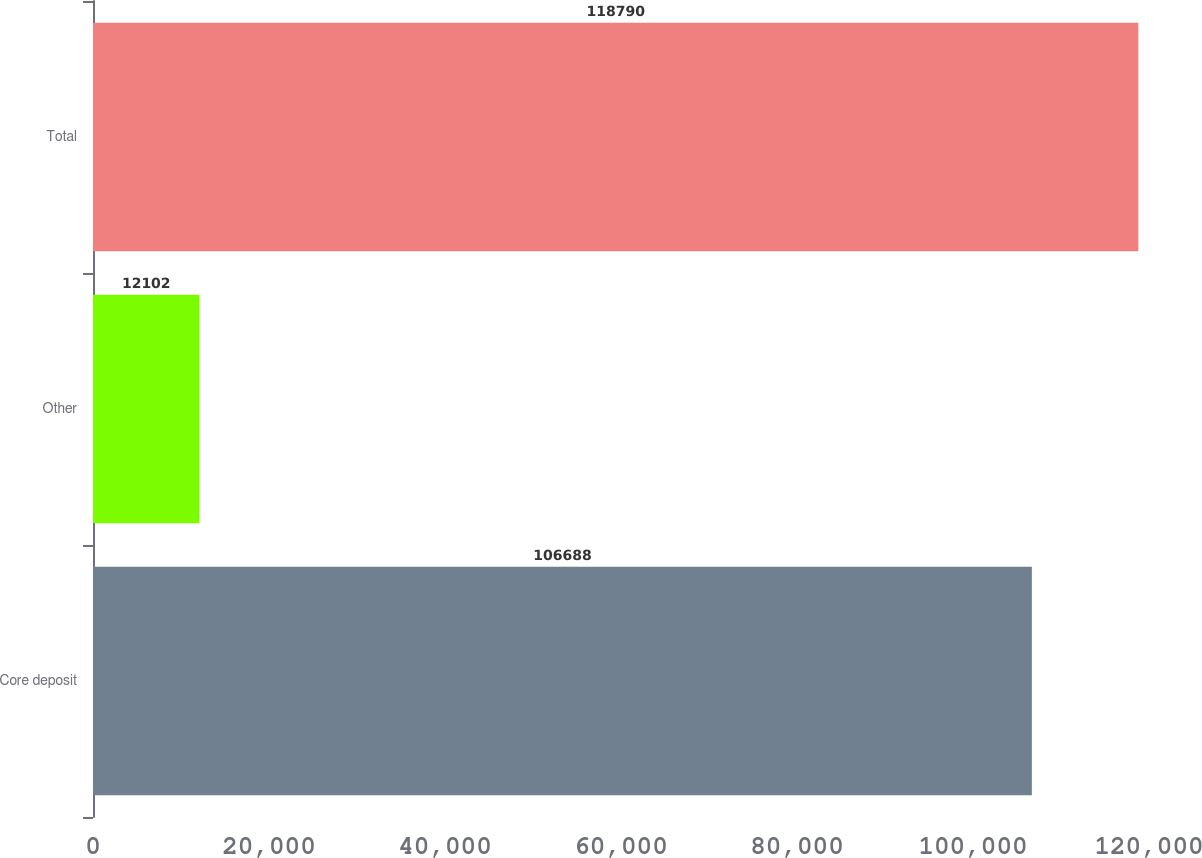<chart> <loc_0><loc_0><loc_500><loc_500><bar_chart><fcel>Core deposit<fcel>Other<fcel>Total<nl><fcel>106688<fcel>12102<fcel>118790<nl></chart> 